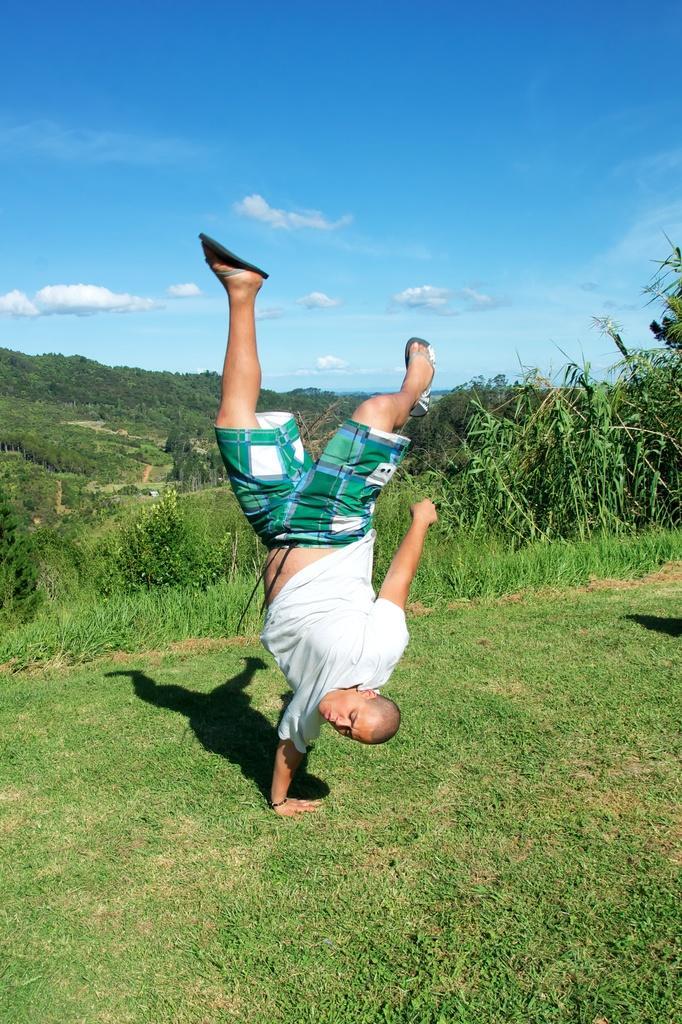Describe this image in one or two sentences. In this image I can see a person visible on the ground and I can see the sky and grass visible in the middle 